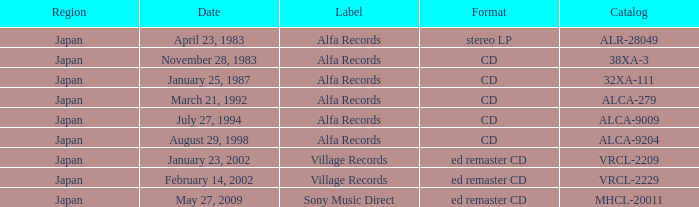Which directory is available in cd format? 38XA-3, 32XA-111, ALCA-279, ALCA-9009, ALCA-9204. 